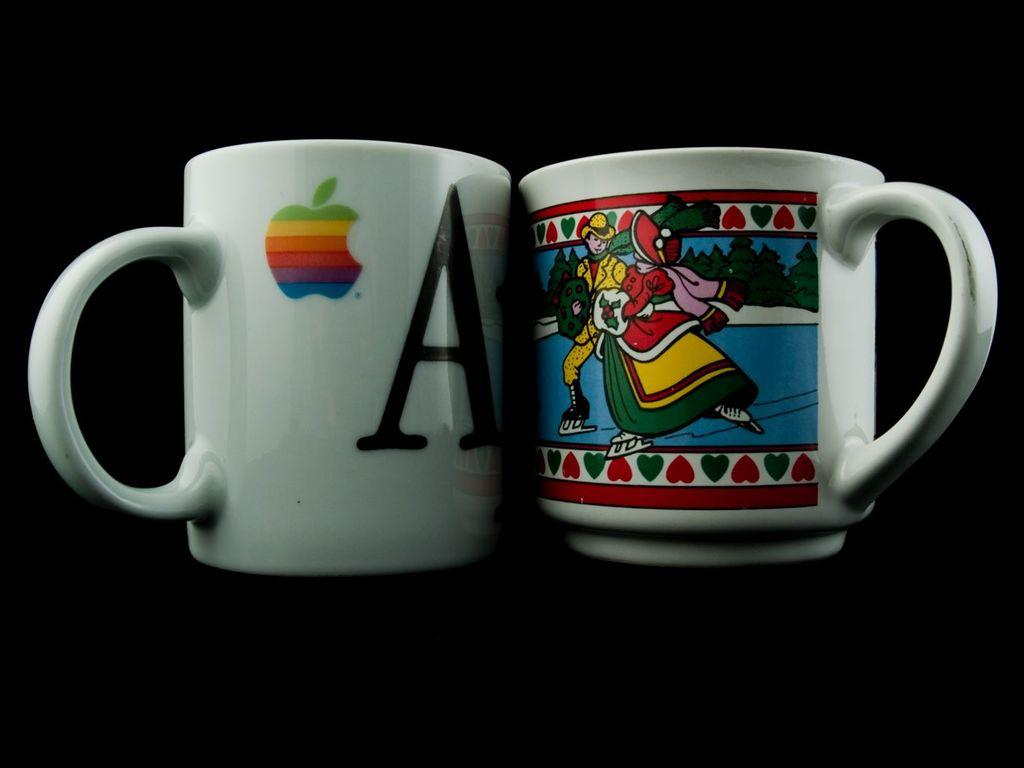What objects are present in the image? There is a pair of cups in the image. Can you describe the cups in more detail? Unfortunately, the provided facts do not offer any additional details about the cups. Are there any other objects or people present in the image? The provided facts do not mention any other objects or people in the image. What type of kitten is playing with the locket in the image? There is no kitten or locket present in the image; it only features a pair of cups. How does the image convey a sense of harmony? The image does not convey a sense of harmony, as it only contains a pair of cups and no other context or elements are provided. 